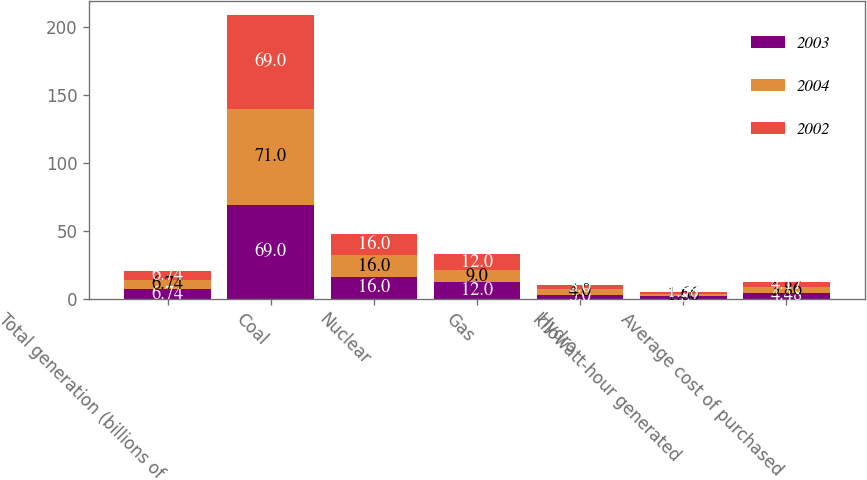Convert chart to OTSL. <chart><loc_0><loc_0><loc_500><loc_500><stacked_bar_chart><ecel><fcel>Total generation (billions of<fcel>Coal<fcel>Nuclear<fcel>Gas<fcel>Hydro<fcel>kilowatt-hour generated<fcel>Average cost of purchased<nl><fcel>2003<fcel>6.74<fcel>69<fcel>16<fcel>12<fcel>3<fcel>1.87<fcel>4.48<nl><fcel>2004<fcel>6.74<fcel>71<fcel>16<fcel>9<fcel>4<fcel>1.66<fcel>3.86<nl><fcel>2002<fcel>6.74<fcel>69<fcel>16<fcel>12<fcel>3<fcel>1.58<fcel>4.17<nl></chart> 